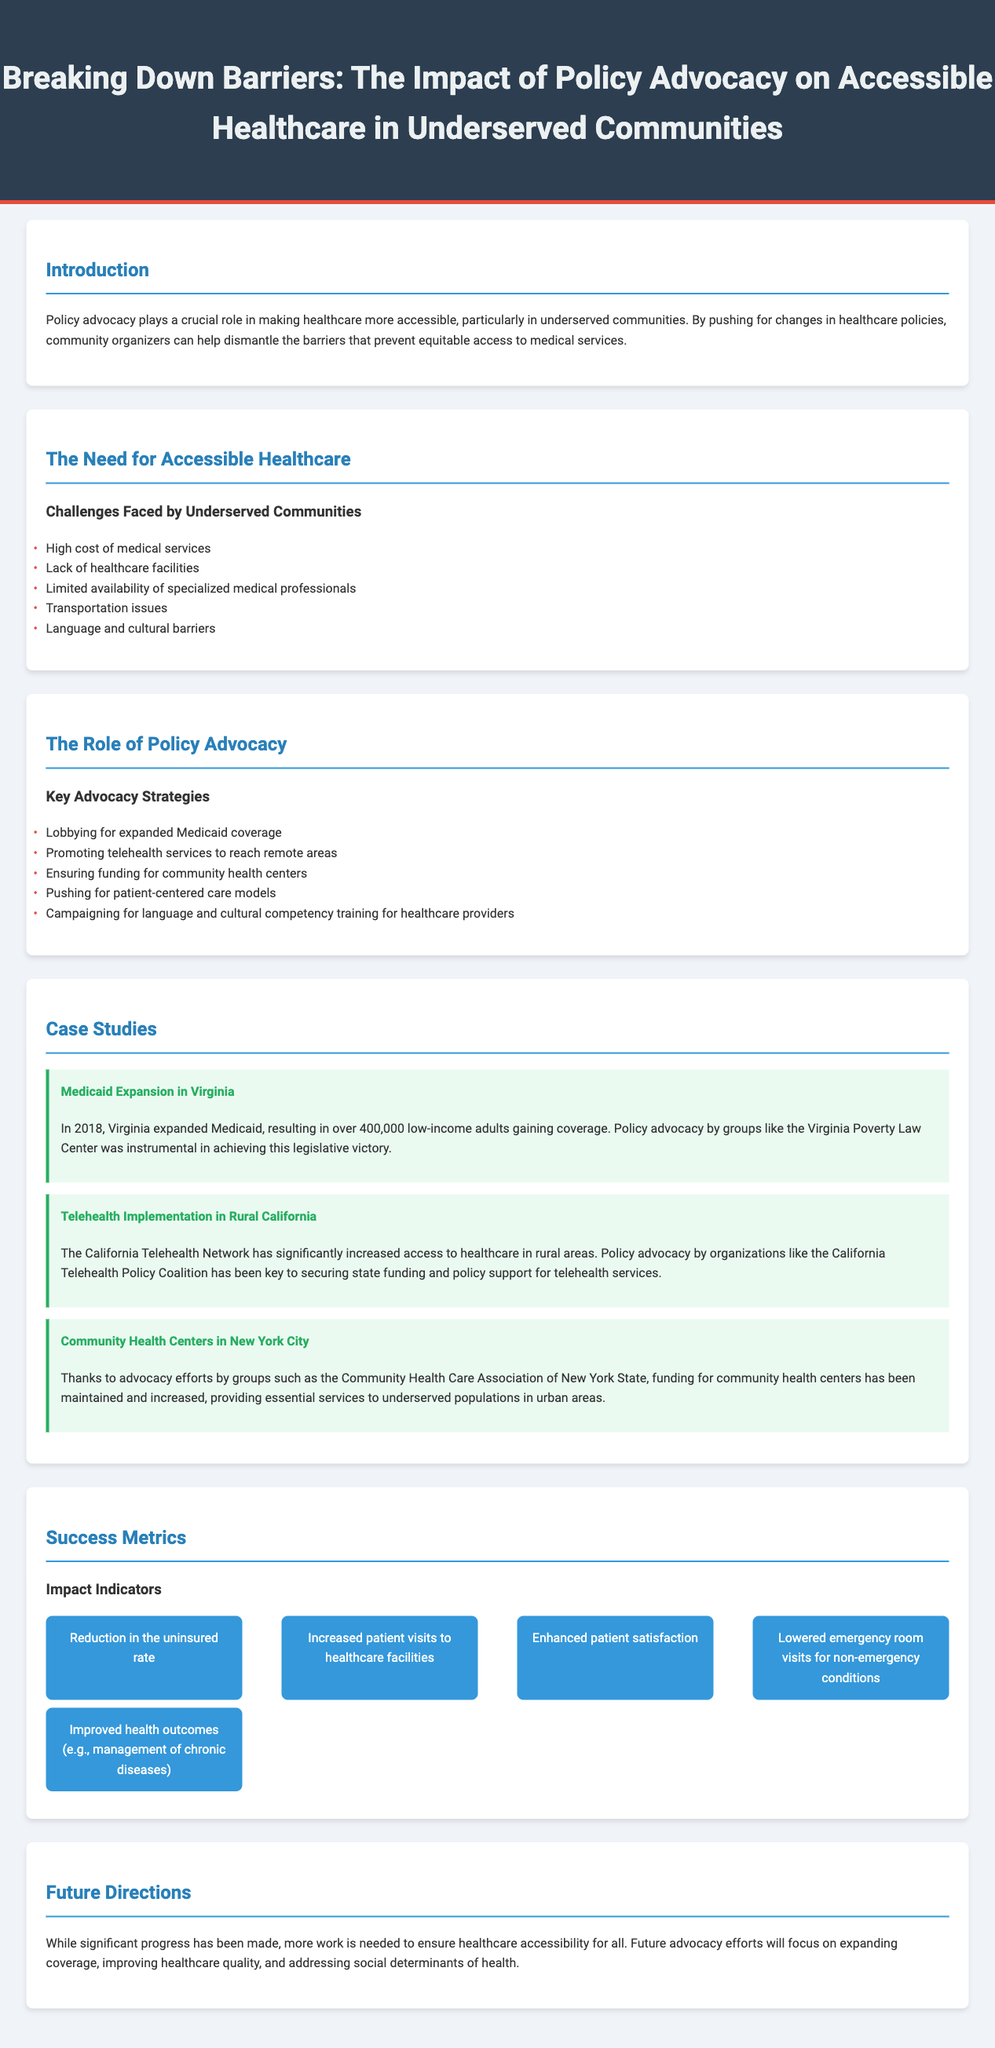What is the title of the infographic? The title of the infographic is provided in the header section, summarizing the main theme of the content.
Answer: Breaking Down Barriers: The Impact of Policy Advocacy on Accessible Healthcare in Underserved Communities How many challenges are listed for underserved communities? The section discusses several specific challenges faced by underserved communities, enumerating them in a list.
Answer: Five What key advocacy strategy focuses on direct healthcare delivery enhancements? This strategy discusses future healthcare availability through modern means, which is aimed at reaching more patients effectively.
Answer: Promoting telehealth services to reach remote areas Which community health center advocacy group is mentioned? The document names a specific group known for its efforts to maintain and increase funding for community health centers.
Answer: Community Health Care Association of New York State What was the outcome of the Medicaid expansion in Virginia? The case study highlights a specific quantitative result following the policy change, demonstrating the impact of advocacy efforts.
Answer: Over 400,000 low-income adults gaining coverage Which metric indicates improved patient experience? The success metrics section outlines various indicators signifying positive effects on healthcare elasticity and satisfaction among patients.
Answer: Enhanced patient satisfaction What is the primary future advocacy focus mentioned? This section indicates the main areas for upcoming policy advocacy efforts related to healthcare access and quality improvements.
Answer: Expanding coverage Which state's rural healthcare access was improved through telehealth? The case studies provide an example of a specific geographic area benefiting from a particular health service strategy.
Answer: California 